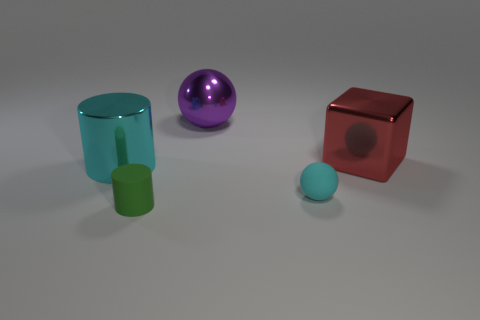Add 2 tiny red cylinders. How many objects exist? 7 Subtract all blocks. How many objects are left? 4 Subtract 1 cylinders. How many cylinders are left? 1 Subtract all purple cylinders. Subtract all purple spheres. How many cylinders are left? 2 Subtract all yellow blocks. How many purple cylinders are left? 0 Subtract all small matte cylinders. Subtract all blocks. How many objects are left? 3 Add 3 purple shiny spheres. How many purple shiny spheres are left? 4 Add 1 matte blocks. How many matte blocks exist? 1 Subtract 1 cyan cylinders. How many objects are left? 4 